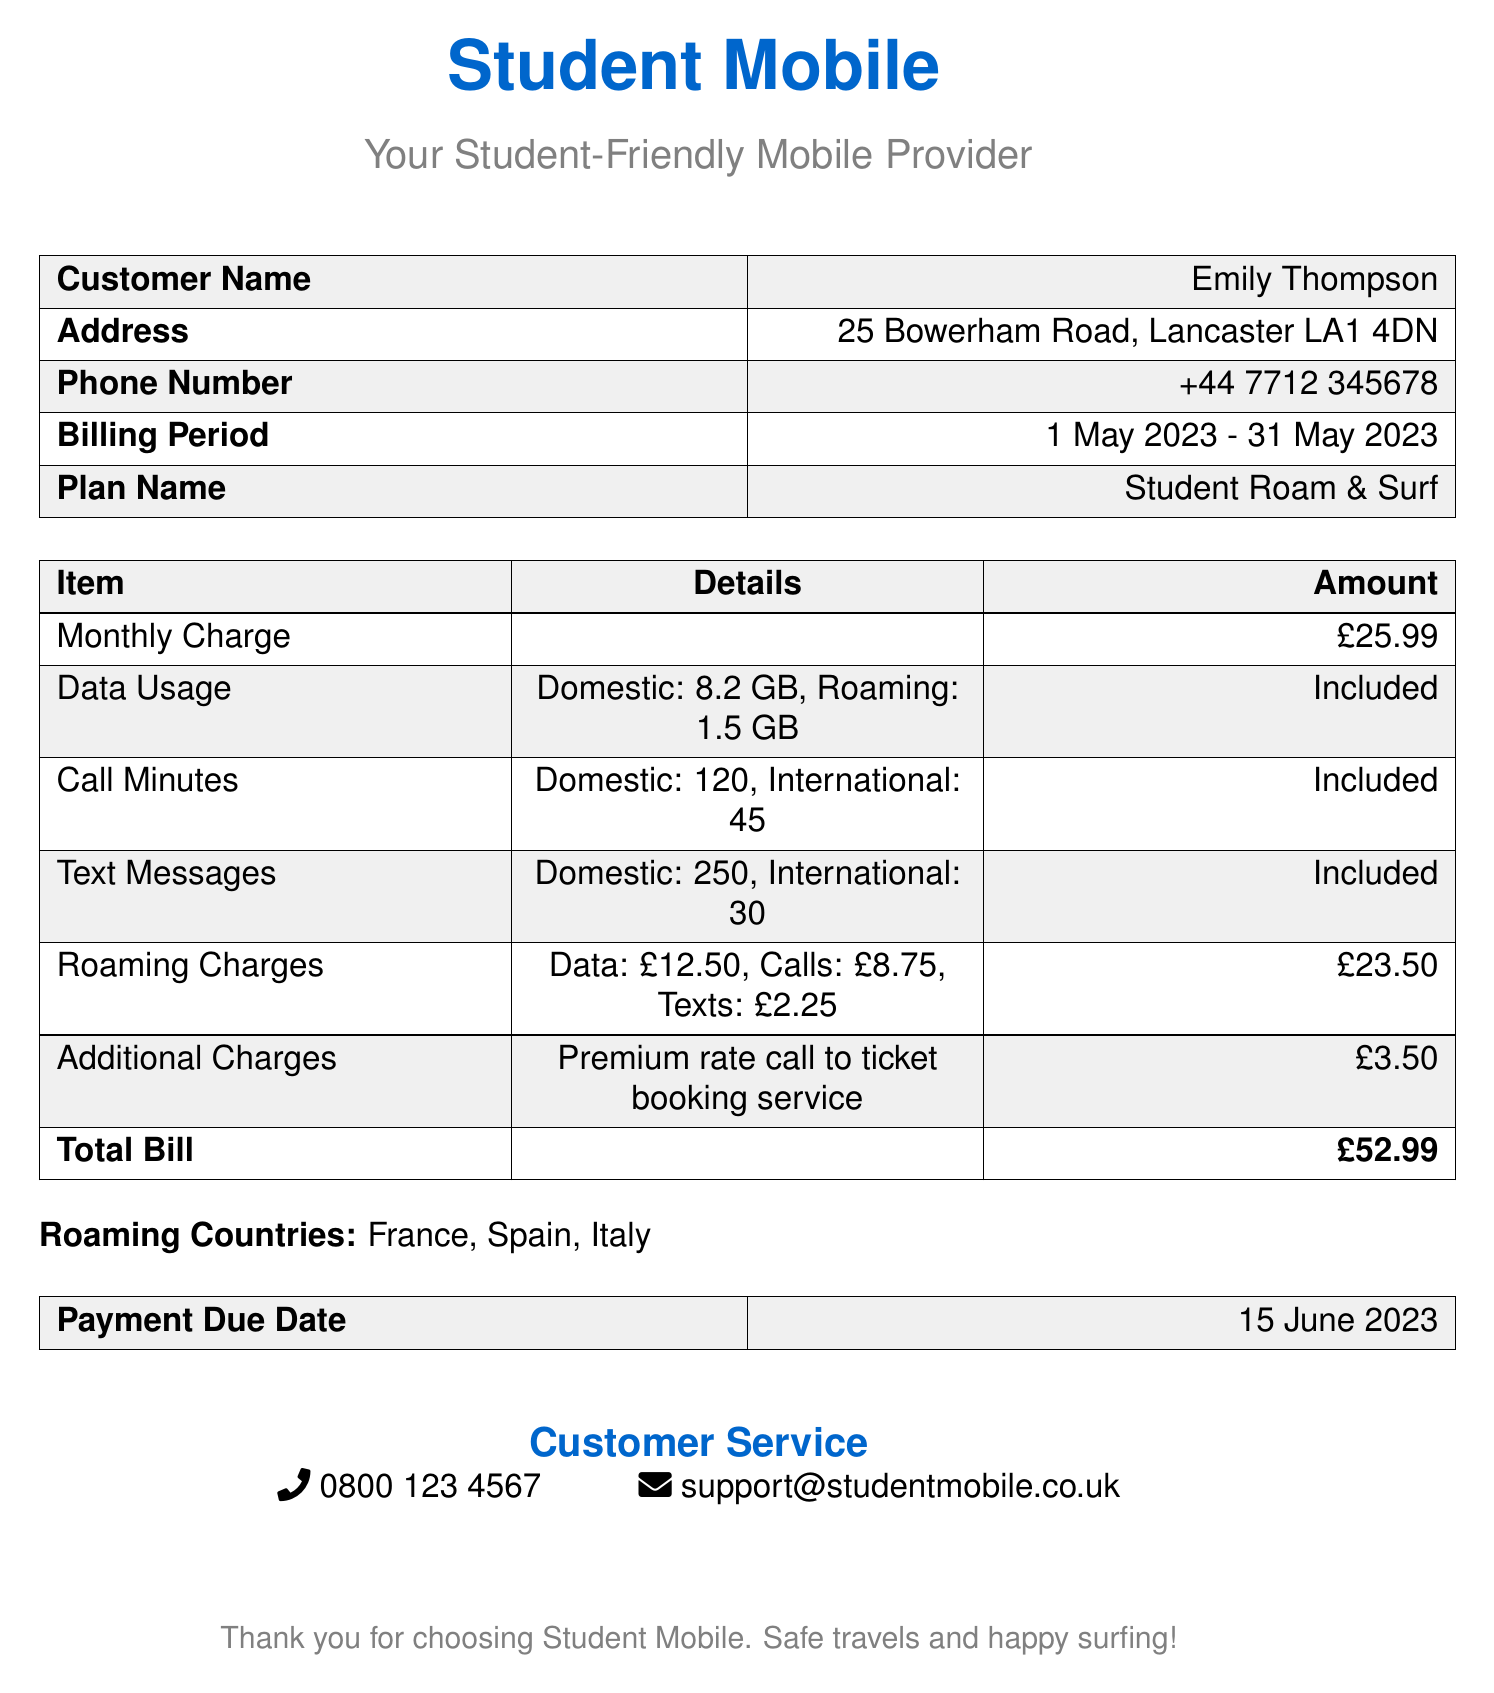What is the customer's name? The customer's name is listed in the document as Emily Thompson.
Answer: Emily Thompson What is the billing period? The billing period is indicated in the document as the time frame for the bill.
Answer: 1 May 2023 - 31 May 2023 How much is the monthly charge? The document specifies the monthly charge for the mobile plan.
Answer: £25.99 What are the total roaming charges? The total roaming charges are detailed in the bill and include various types of charges.
Answer: £23.50 How many domestic call minutes are included? The document specifies the number of domestic call minutes included in the plan.
Answer: 120 What countries are listed under roaming countries? The document lists countries where roaming is available during travel.
Answer: France, Spain, Italy What is the payment due date? The payment due date is clearly stated in the document, requiring attention for timely payment.
Answer: 15 June 2023 Which additional charge is mentioned? The document includes a specific additional charge that has been incurred.
Answer: Premium rate call to ticket booking service How many text messages are included internationally? The number of international text messages included is provided in the document.
Answer: 30 